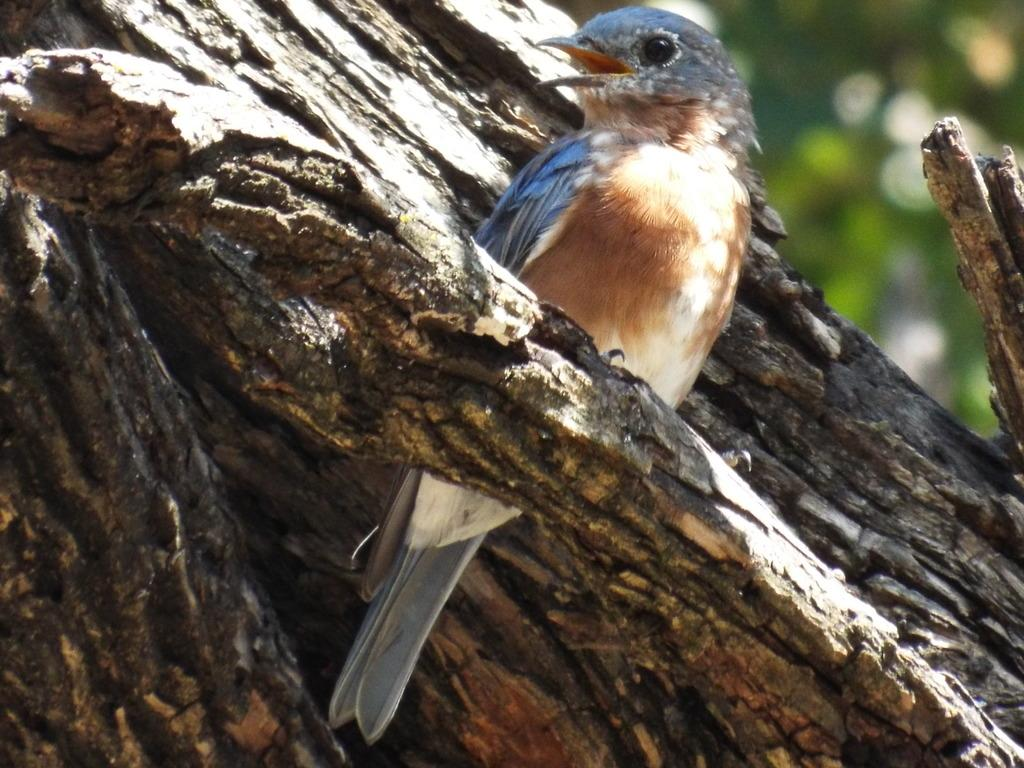What type of animal is in the image? There is a bird in the image. Where is the bird located? The bird is on a tree trunk. Can you describe the background of the image? The background of the image is blurred. How many giants can be seen interacting with the bird in the image? There are no giants present in the image. What type of horse is visible in the image? There is no horse present in the image. 